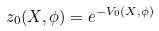<formula> <loc_0><loc_0><loc_500><loc_500>z _ { 0 } ( X , \phi ) = e ^ { - V _ { 0 } ( X , \phi ) }</formula> 